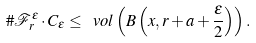Convert formula to latex. <formula><loc_0><loc_0><loc_500><loc_500>\# \mathcal { F } _ { r } ^ { \varepsilon } \cdot C _ { \varepsilon } \leq \ v o l \left ( B \left ( x , r + a + \frac { \varepsilon } { 2 } \right ) \right ) .</formula> 